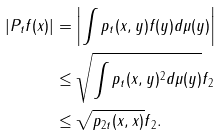<formula> <loc_0><loc_0><loc_500><loc_500>| P _ { t } f ( x ) | & = \left | \int p _ { t } ( x , y ) f ( y ) d \mu ( y ) \right | \\ & \leq \sqrt { \int p _ { t } ( x , y ) ^ { 2 } d \mu ( y ) } \| f \| _ { 2 } \\ & \leq \sqrt { p _ { 2 t } ( x , x ) } \| f \| _ { 2 } .</formula> 